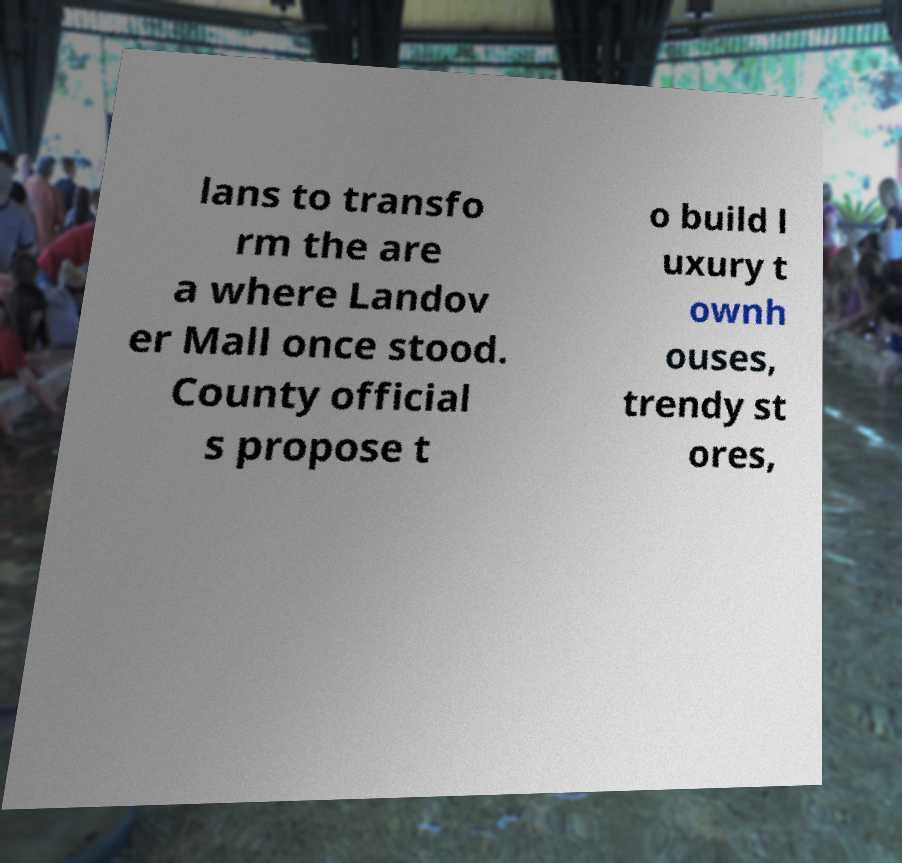What messages or text are displayed in this image? I need them in a readable, typed format. lans to transfo rm the are a where Landov er Mall once stood. County official s propose t o build l uxury t ownh ouses, trendy st ores, 